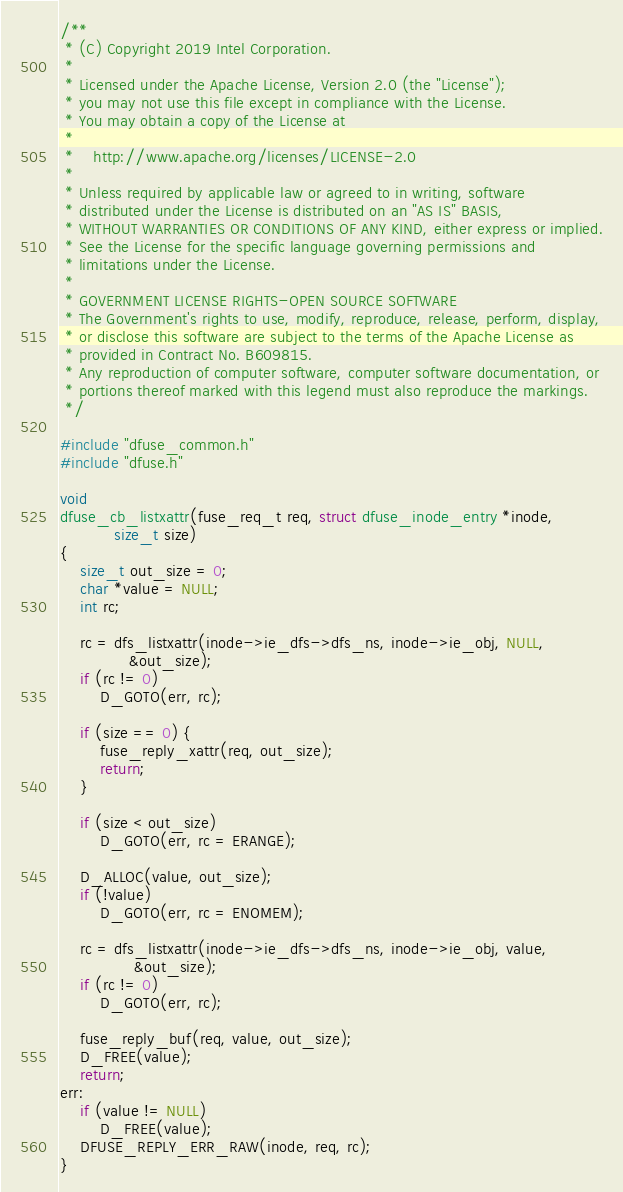Convert code to text. <code><loc_0><loc_0><loc_500><loc_500><_C_>/**
 * (C) Copyright 2019 Intel Corporation.
 *
 * Licensed under the Apache License, Version 2.0 (the "License");
 * you may not use this file except in compliance with the License.
 * You may obtain a copy of the License at
 *
 *    http://www.apache.org/licenses/LICENSE-2.0
 *
 * Unless required by applicable law or agreed to in writing, software
 * distributed under the License is distributed on an "AS IS" BASIS,
 * WITHOUT WARRANTIES OR CONDITIONS OF ANY KIND, either express or implied.
 * See the License for the specific language governing permissions and
 * limitations under the License.
 *
 * GOVERNMENT LICENSE RIGHTS-OPEN SOURCE SOFTWARE
 * The Government's rights to use, modify, reproduce, release, perform, display,
 * or disclose this software are subject to the terms of the Apache License as
 * provided in Contract No. B609815.
 * Any reproduction of computer software, computer software documentation, or
 * portions thereof marked with this legend must also reproduce the markings.
 */

#include "dfuse_common.h"
#include "dfuse.h"

void
dfuse_cb_listxattr(fuse_req_t req, struct dfuse_inode_entry *inode,
		   size_t size)
{
	size_t out_size = 0;
	char *value = NULL;
	int rc;

	rc = dfs_listxattr(inode->ie_dfs->dfs_ns, inode->ie_obj, NULL,
			  &out_size);
	if (rc != 0)
		D_GOTO(err, rc);

	if (size == 0) {
		fuse_reply_xattr(req, out_size);
		return;
	}

	if (size < out_size)
		D_GOTO(err, rc = ERANGE);

	D_ALLOC(value, out_size);
	if (!value)
		D_GOTO(err, rc = ENOMEM);

	rc = dfs_listxattr(inode->ie_dfs->dfs_ns, inode->ie_obj, value,
			   &out_size);
	if (rc != 0)
		D_GOTO(err, rc);

	fuse_reply_buf(req, value, out_size);
	D_FREE(value);
	return;
err:
	if (value != NULL)
		D_FREE(value);
	DFUSE_REPLY_ERR_RAW(inode, req, rc);
}
</code> 